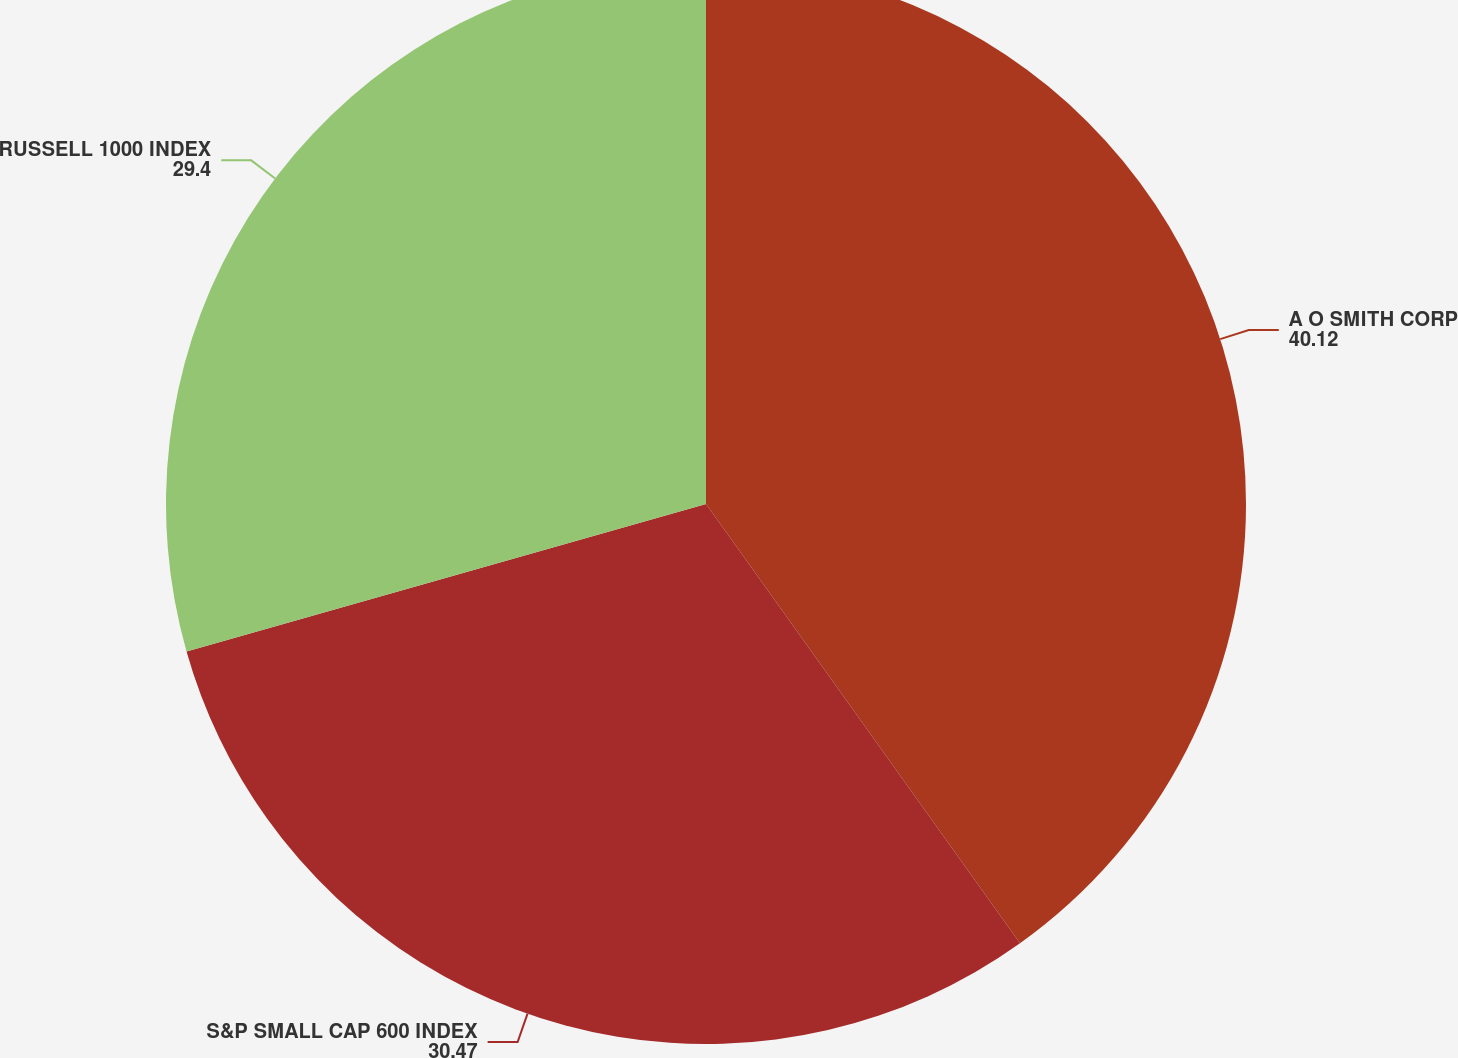Convert chart. <chart><loc_0><loc_0><loc_500><loc_500><pie_chart><fcel>A O SMITH CORP<fcel>S&P SMALL CAP 600 INDEX<fcel>RUSSELL 1000 INDEX<nl><fcel>40.12%<fcel>30.47%<fcel>29.4%<nl></chart> 